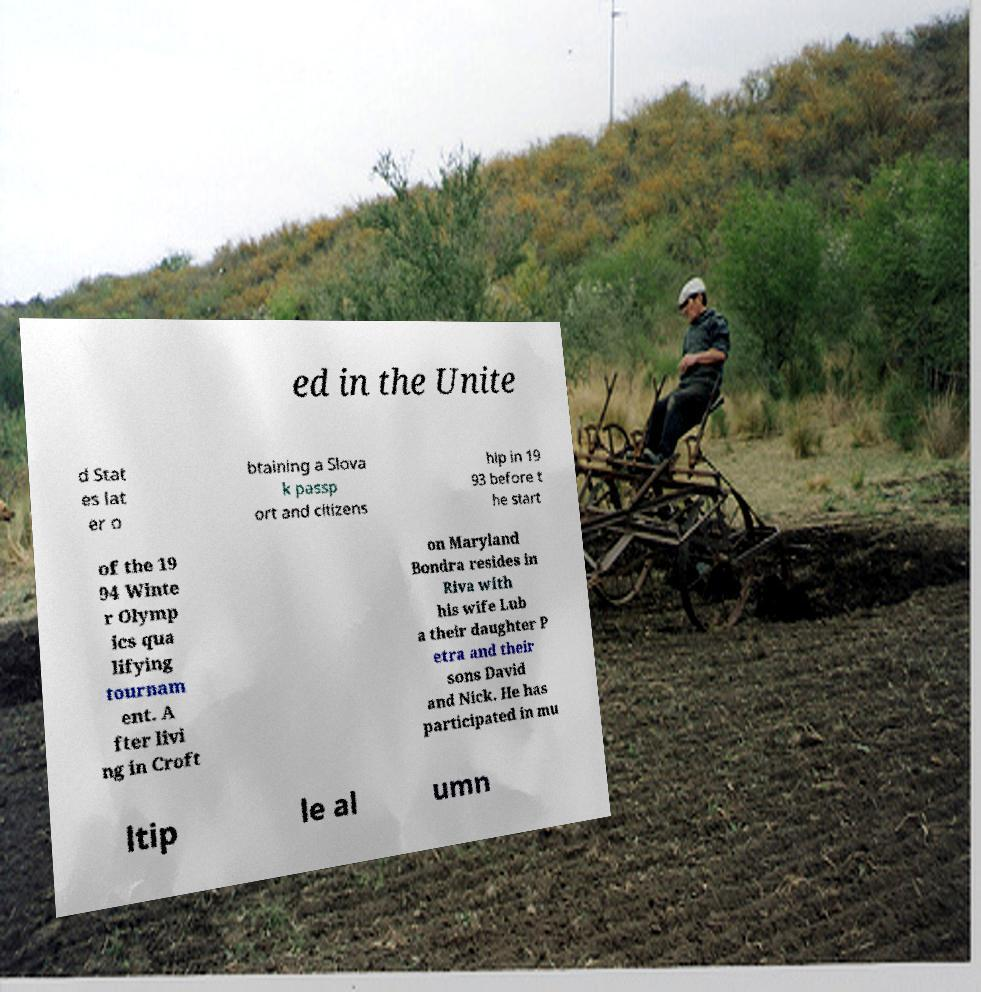Could you assist in decoding the text presented in this image and type it out clearly? ed in the Unite d Stat es lat er o btaining a Slova k passp ort and citizens hip in 19 93 before t he start of the 19 94 Winte r Olymp ics qua lifying tournam ent. A fter livi ng in Croft on Maryland Bondra resides in Riva with his wife Lub a their daughter P etra and their sons David and Nick. He has participated in mu ltip le al umn 